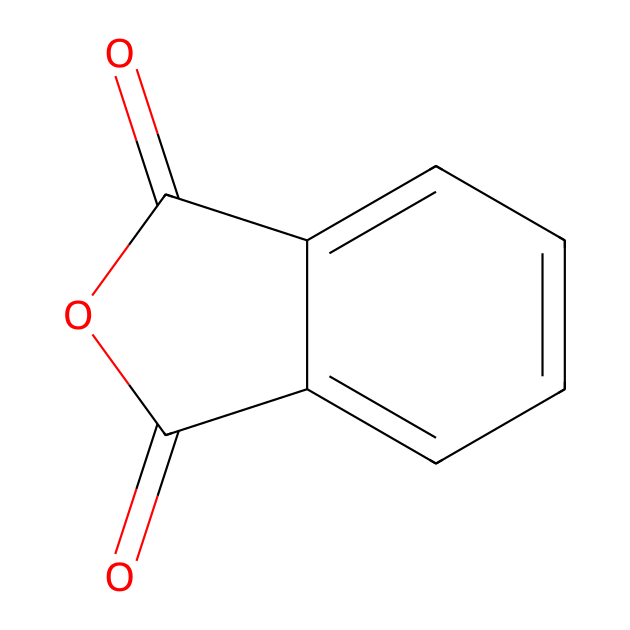What is the molecular formula of phthalic anhydride? The structure shows two carbonyl groups (C=O) and a ring, indicating a total of 8 carbon atoms and 4 oxygen atoms in the molecule. The empirical formula can be derived from counting the atoms in the structure.
Answer: C8H4O3 How many carbon atoms are in phthalic anhydride? By analyzing the structural formula, you can visually count the carbon atoms present, which indicates there are 8 carbon atoms in total.
Answer: 8 What type of functional groups are present in phthalic anhydride? The chemical consists of two carbonyl groups and an anhydride functional group, which is characterized by the presence of two acyl groups bonded to the same oxygen atom.
Answer: anhydride How many rings are in the structure of phthalic anhydride? The structure shows a single aromatic ring connected to the anhydride functionality, leading to the conclusion that there is one ring present.
Answer: 1 Is phthalic anhydride a saturated or unsaturated compound? Examining the number of double bonds in the structure reveals that there are carbon-carbon double bonds present, indicating that the compound is unsaturated.
Answer: unsaturated What is the characteristic property of phthalic anhydride as an acid anhydride? As an acid anhydride, phthalic anhydride reacts with water to form corresponding acids and can also undergo reactions with alcohols to form esters, which reflects its reactivity characteristic.
Answer: reactivity How many oxygen atoms are in phthalic anhydride? By inspecting the structure, you can see that there are 3 oxygen atoms present, including the two carbonyls and one in the anhydride linkage.
Answer: 3 